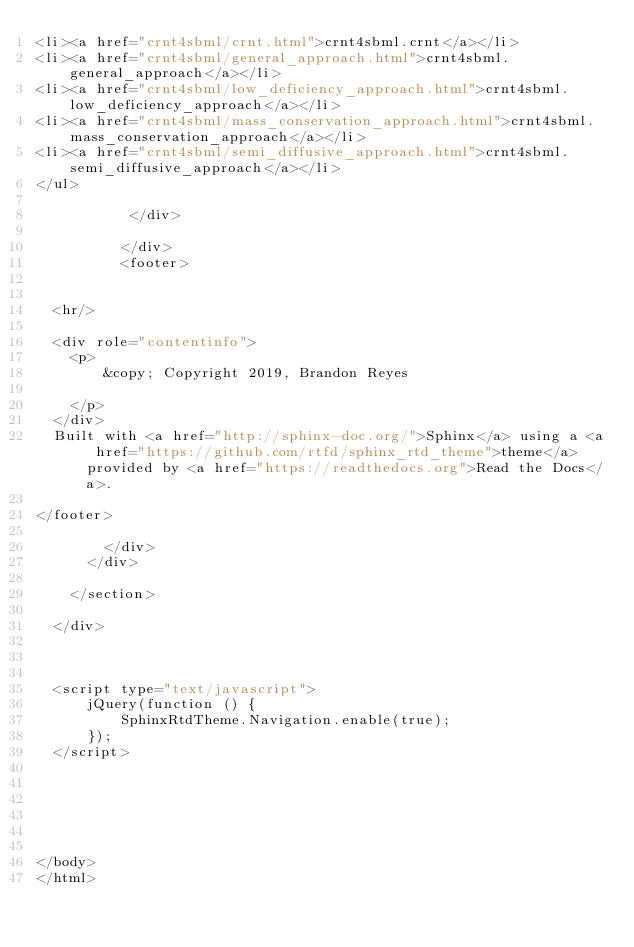Convert code to text. <code><loc_0><loc_0><loc_500><loc_500><_HTML_><li><a href="crnt4sbml/crnt.html">crnt4sbml.crnt</a></li>
<li><a href="crnt4sbml/general_approach.html">crnt4sbml.general_approach</a></li>
<li><a href="crnt4sbml/low_deficiency_approach.html">crnt4sbml.low_deficiency_approach</a></li>
<li><a href="crnt4sbml/mass_conservation_approach.html">crnt4sbml.mass_conservation_approach</a></li>
<li><a href="crnt4sbml/semi_diffusive_approach.html">crnt4sbml.semi_diffusive_approach</a></li>
</ul>

           </div>
           
          </div>
          <footer>
  

  <hr/>

  <div role="contentinfo">
    <p>
        &copy; Copyright 2019, Brandon Reyes

    </p>
  </div>
  Built with <a href="http://sphinx-doc.org/">Sphinx</a> using a <a href="https://github.com/rtfd/sphinx_rtd_theme">theme</a> provided by <a href="https://readthedocs.org">Read the Docs</a>. 

</footer>

        </div>
      </div>

    </section>

  </div>
  


  <script type="text/javascript">
      jQuery(function () {
          SphinxRtdTheme.Navigation.enable(true);
      });
  </script>

  
  
    
   

</body>
</html></code> 